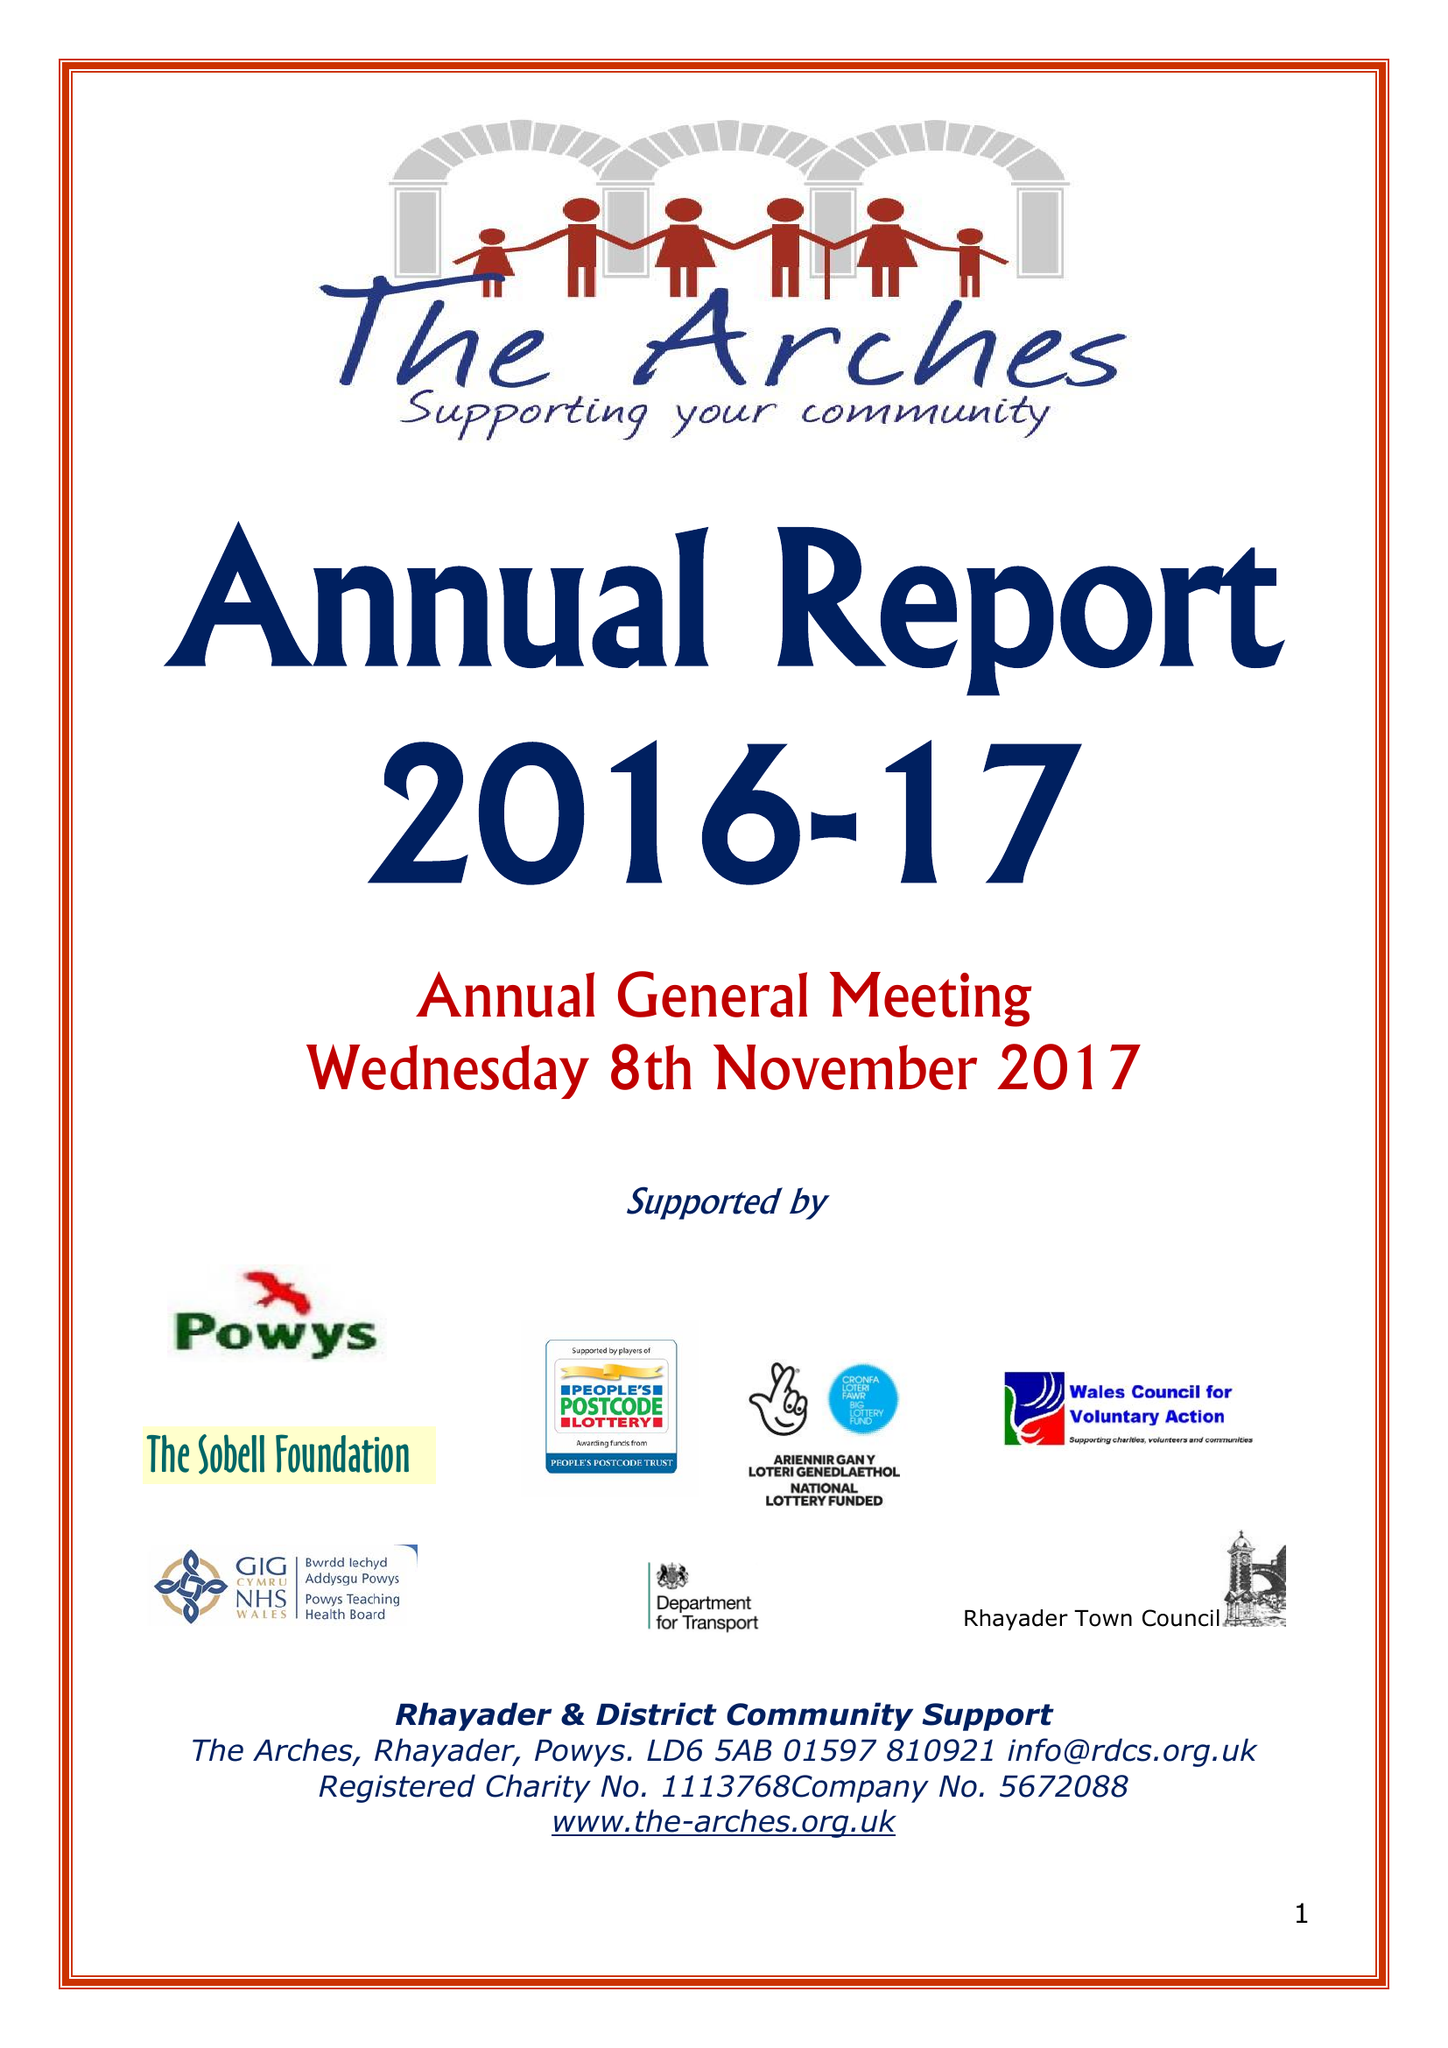What is the value for the address__street_line?
Answer the question using a single word or phrase. WEST STREET 